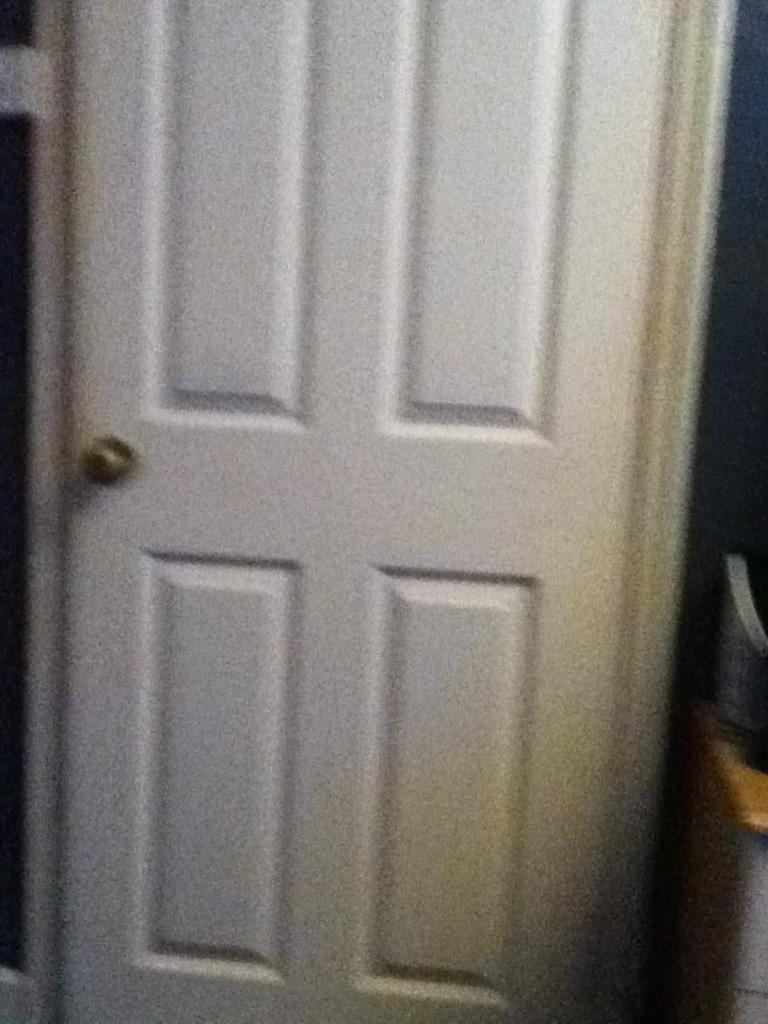What is present in the image that serves as an entrance or exit? There is a door in the image. What color is the door in the image? The door is white in color. Is there an umbrella being used as a secretary in the image? There is no umbrella or secretary present in the image. 